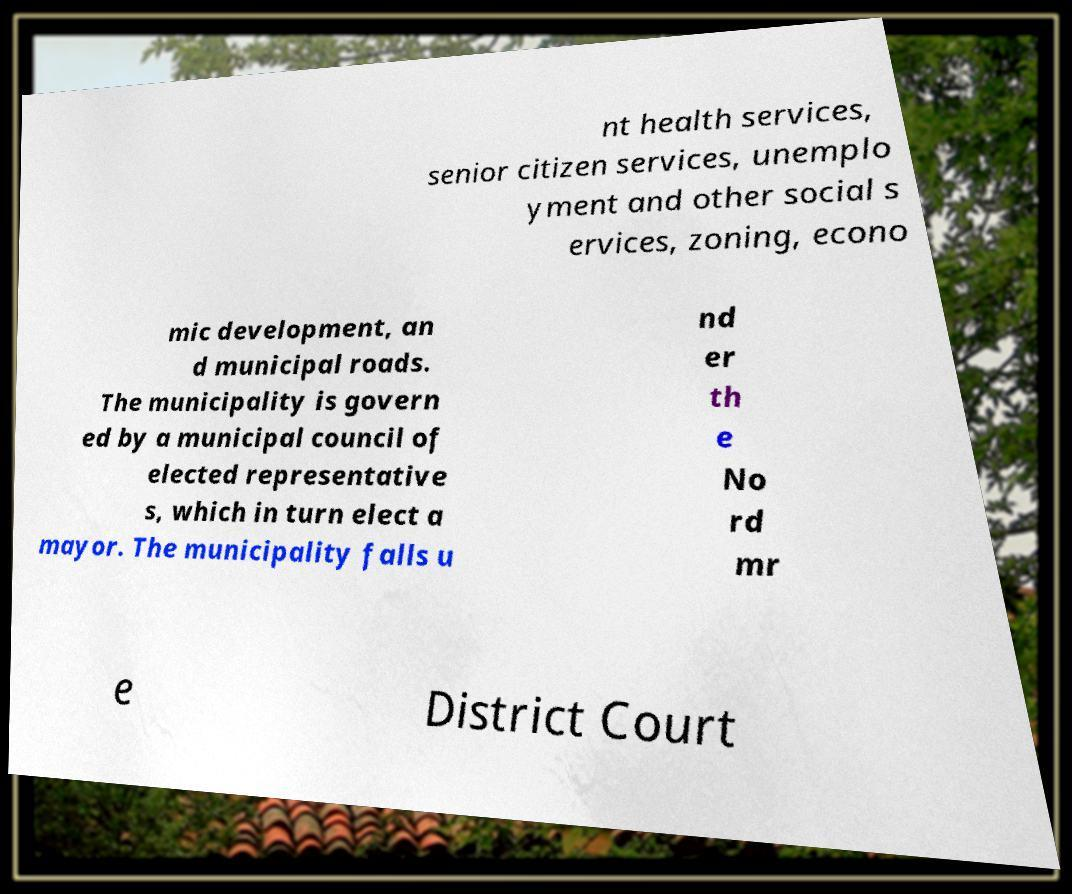Could you extract and type out the text from this image? nt health services, senior citizen services, unemplo yment and other social s ervices, zoning, econo mic development, an d municipal roads. The municipality is govern ed by a municipal council of elected representative s, which in turn elect a mayor. The municipality falls u nd er th e No rd mr e District Court 